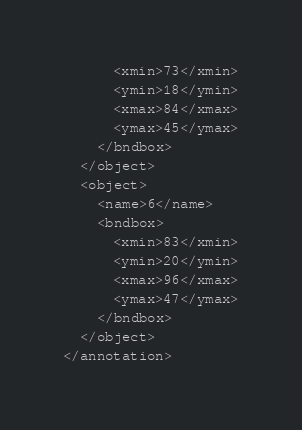Convert code to text. <code><loc_0><loc_0><loc_500><loc_500><_XML_>      <xmin>73</xmin>
      <ymin>18</ymin>
      <xmax>84</xmax>
      <ymax>45</ymax>
    </bndbox>
  </object>
  <object>
    <name>6</name>
    <bndbox>
      <xmin>83</xmin>
      <ymin>20</ymin>
      <xmax>96</xmax>
      <ymax>47</ymax>
    </bndbox>
  </object>
</annotation>
</code> 